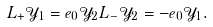Convert formula to latex. <formula><loc_0><loc_0><loc_500><loc_500>L _ { + } \mathcal { Y } _ { 1 } = e _ { 0 } \mathcal { Y } _ { 2 } L _ { - } \mathcal { Y } _ { 2 } = - e _ { 0 } \mathcal { Y } _ { 1 } .</formula> 